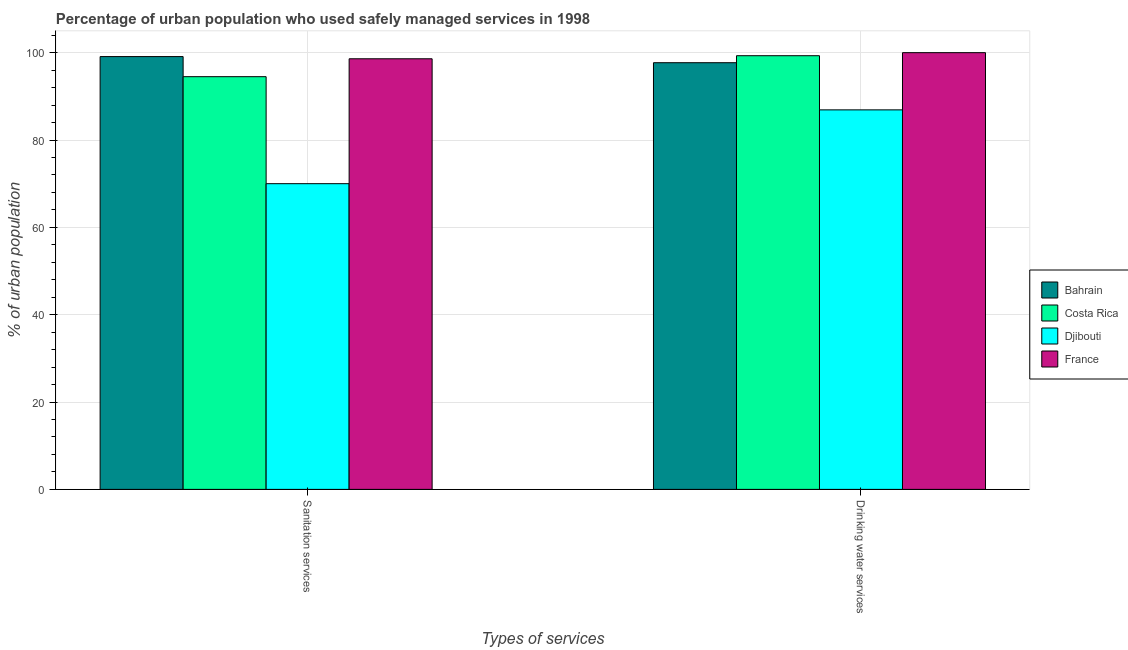How many bars are there on the 2nd tick from the left?
Make the answer very short. 4. How many bars are there on the 2nd tick from the right?
Provide a short and direct response. 4. What is the label of the 1st group of bars from the left?
Offer a terse response. Sanitation services. What is the percentage of urban population who used drinking water services in Bahrain?
Ensure brevity in your answer.  97.7. Across all countries, what is the maximum percentage of urban population who used drinking water services?
Your answer should be compact. 100. Across all countries, what is the minimum percentage of urban population who used drinking water services?
Offer a terse response. 86.9. In which country was the percentage of urban population who used sanitation services maximum?
Provide a short and direct response. Bahrain. In which country was the percentage of urban population who used sanitation services minimum?
Offer a terse response. Djibouti. What is the total percentage of urban population who used sanitation services in the graph?
Your answer should be very brief. 362.2. What is the difference between the percentage of urban population who used drinking water services in France and that in Costa Rica?
Provide a succinct answer. 0.7. What is the difference between the percentage of urban population who used drinking water services in Bahrain and the percentage of urban population who used sanitation services in Costa Rica?
Make the answer very short. 3.2. What is the average percentage of urban population who used sanitation services per country?
Provide a succinct answer. 90.55. What is the difference between the percentage of urban population who used sanitation services and percentage of urban population who used drinking water services in Bahrain?
Your response must be concise. 1.4. In how many countries, is the percentage of urban population who used drinking water services greater than 84 %?
Provide a short and direct response. 4. What is the ratio of the percentage of urban population who used sanitation services in Djibouti to that in Bahrain?
Offer a very short reply. 0.71. Is the percentage of urban population who used sanitation services in Bahrain less than that in Costa Rica?
Give a very brief answer. No. What does the 4th bar from the left in Sanitation services represents?
Make the answer very short. France. What does the 3rd bar from the right in Drinking water services represents?
Provide a succinct answer. Costa Rica. Does the graph contain grids?
Keep it short and to the point. Yes. Where does the legend appear in the graph?
Provide a short and direct response. Center right. How are the legend labels stacked?
Your answer should be very brief. Vertical. What is the title of the graph?
Offer a very short reply. Percentage of urban population who used safely managed services in 1998. Does "Senegal" appear as one of the legend labels in the graph?
Provide a short and direct response. No. What is the label or title of the X-axis?
Ensure brevity in your answer.  Types of services. What is the label or title of the Y-axis?
Provide a short and direct response. % of urban population. What is the % of urban population in Bahrain in Sanitation services?
Keep it short and to the point. 99.1. What is the % of urban population of Costa Rica in Sanitation services?
Ensure brevity in your answer.  94.5. What is the % of urban population in France in Sanitation services?
Your answer should be compact. 98.6. What is the % of urban population in Bahrain in Drinking water services?
Keep it short and to the point. 97.7. What is the % of urban population in Costa Rica in Drinking water services?
Offer a terse response. 99.3. What is the % of urban population in Djibouti in Drinking water services?
Offer a terse response. 86.9. What is the % of urban population in France in Drinking water services?
Offer a terse response. 100. Across all Types of services, what is the maximum % of urban population of Bahrain?
Your response must be concise. 99.1. Across all Types of services, what is the maximum % of urban population of Costa Rica?
Offer a terse response. 99.3. Across all Types of services, what is the maximum % of urban population in Djibouti?
Keep it short and to the point. 86.9. Across all Types of services, what is the maximum % of urban population in France?
Make the answer very short. 100. Across all Types of services, what is the minimum % of urban population in Bahrain?
Your response must be concise. 97.7. Across all Types of services, what is the minimum % of urban population of Costa Rica?
Offer a terse response. 94.5. Across all Types of services, what is the minimum % of urban population of France?
Keep it short and to the point. 98.6. What is the total % of urban population in Bahrain in the graph?
Keep it short and to the point. 196.8. What is the total % of urban population of Costa Rica in the graph?
Offer a very short reply. 193.8. What is the total % of urban population in Djibouti in the graph?
Your response must be concise. 156.9. What is the total % of urban population in France in the graph?
Ensure brevity in your answer.  198.6. What is the difference between the % of urban population in Djibouti in Sanitation services and that in Drinking water services?
Offer a terse response. -16.9. What is the difference between the % of urban population in Bahrain in Sanitation services and the % of urban population in Costa Rica in Drinking water services?
Your answer should be very brief. -0.2. What is the difference between the % of urban population of Bahrain in Sanitation services and the % of urban population of Djibouti in Drinking water services?
Offer a terse response. 12.2. What is the difference between the % of urban population of Bahrain in Sanitation services and the % of urban population of France in Drinking water services?
Make the answer very short. -0.9. What is the difference between the % of urban population in Costa Rica in Sanitation services and the % of urban population in Djibouti in Drinking water services?
Your answer should be compact. 7.6. What is the average % of urban population of Bahrain per Types of services?
Offer a very short reply. 98.4. What is the average % of urban population in Costa Rica per Types of services?
Offer a terse response. 96.9. What is the average % of urban population of Djibouti per Types of services?
Give a very brief answer. 78.45. What is the average % of urban population of France per Types of services?
Offer a very short reply. 99.3. What is the difference between the % of urban population of Bahrain and % of urban population of Costa Rica in Sanitation services?
Your answer should be compact. 4.6. What is the difference between the % of urban population in Bahrain and % of urban population in Djibouti in Sanitation services?
Offer a terse response. 29.1. What is the difference between the % of urban population in Bahrain and % of urban population in France in Sanitation services?
Provide a succinct answer. 0.5. What is the difference between the % of urban population in Costa Rica and % of urban population in France in Sanitation services?
Make the answer very short. -4.1. What is the difference between the % of urban population in Djibouti and % of urban population in France in Sanitation services?
Your response must be concise. -28.6. What is the difference between the % of urban population in Bahrain and % of urban population in France in Drinking water services?
Keep it short and to the point. -2.3. What is the difference between the % of urban population in Costa Rica and % of urban population in Djibouti in Drinking water services?
Provide a short and direct response. 12.4. What is the difference between the % of urban population of Costa Rica and % of urban population of France in Drinking water services?
Your response must be concise. -0.7. What is the difference between the % of urban population in Djibouti and % of urban population in France in Drinking water services?
Your answer should be compact. -13.1. What is the ratio of the % of urban population in Bahrain in Sanitation services to that in Drinking water services?
Give a very brief answer. 1.01. What is the ratio of the % of urban population of Costa Rica in Sanitation services to that in Drinking water services?
Offer a terse response. 0.95. What is the ratio of the % of urban population in Djibouti in Sanitation services to that in Drinking water services?
Your answer should be very brief. 0.81. What is the difference between the highest and the second highest % of urban population of Djibouti?
Keep it short and to the point. 16.9. What is the difference between the highest and the second highest % of urban population in France?
Make the answer very short. 1.4. What is the difference between the highest and the lowest % of urban population in Costa Rica?
Your answer should be very brief. 4.8. What is the difference between the highest and the lowest % of urban population of Djibouti?
Make the answer very short. 16.9. 